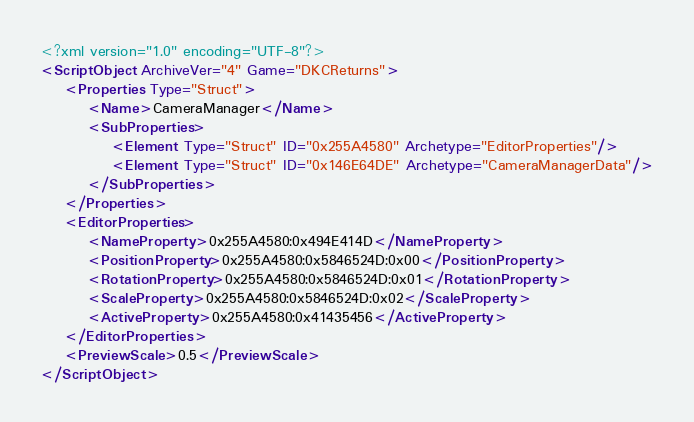<code> <loc_0><loc_0><loc_500><loc_500><_XML_><?xml version="1.0" encoding="UTF-8"?>
<ScriptObject ArchiveVer="4" Game="DKCReturns">
    <Properties Type="Struct">
        <Name>CameraManager</Name>
        <SubProperties>
            <Element Type="Struct" ID="0x255A4580" Archetype="EditorProperties"/>
            <Element Type="Struct" ID="0x146E64DE" Archetype="CameraManagerData"/>
        </SubProperties>
    </Properties>
    <EditorProperties>
        <NameProperty>0x255A4580:0x494E414D</NameProperty>
        <PositionProperty>0x255A4580:0x5846524D:0x00</PositionProperty>
        <RotationProperty>0x255A4580:0x5846524D:0x01</RotationProperty>
        <ScaleProperty>0x255A4580:0x5846524D:0x02</ScaleProperty>
        <ActiveProperty>0x255A4580:0x41435456</ActiveProperty>
    </EditorProperties>
    <PreviewScale>0.5</PreviewScale>
</ScriptObject>
</code> 